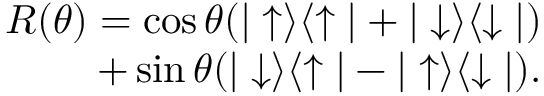Convert formula to latex. <formula><loc_0><loc_0><loc_500><loc_500>\begin{array} { r } { R ( \theta ) = \cos { \theta } ( | \uparrow \rangle \langle \uparrow | + | \downarrow \rangle \langle \downarrow | ) } \\ { + \sin { \theta } ( | \downarrow \rangle \langle \uparrow | - | \uparrow \rangle \langle \downarrow | ) . } \end{array}</formula> 